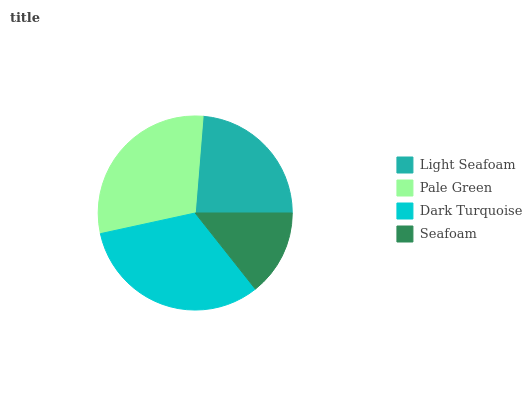Is Seafoam the minimum?
Answer yes or no. Yes. Is Dark Turquoise the maximum?
Answer yes or no. Yes. Is Pale Green the minimum?
Answer yes or no. No. Is Pale Green the maximum?
Answer yes or no. No. Is Pale Green greater than Light Seafoam?
Answer yes or no. Yes. Is Light Seafoam less than Pale Green?
Answer yes or no. Yes. Is Light Seafoam greater than Pale Green?
Answer yes or no. No. Is Pale Green less than Light Seafoam?
Answer yes or no. No. Is Pale Green the high median?
Answer yes or no. Yes. Is Light Seafoam the low median?
Answer yes or no. Yes. Is Dark Turquoise the high median?
Answer yes or no. No. Is Seafoam the low median?
Answer yes or no. No. 